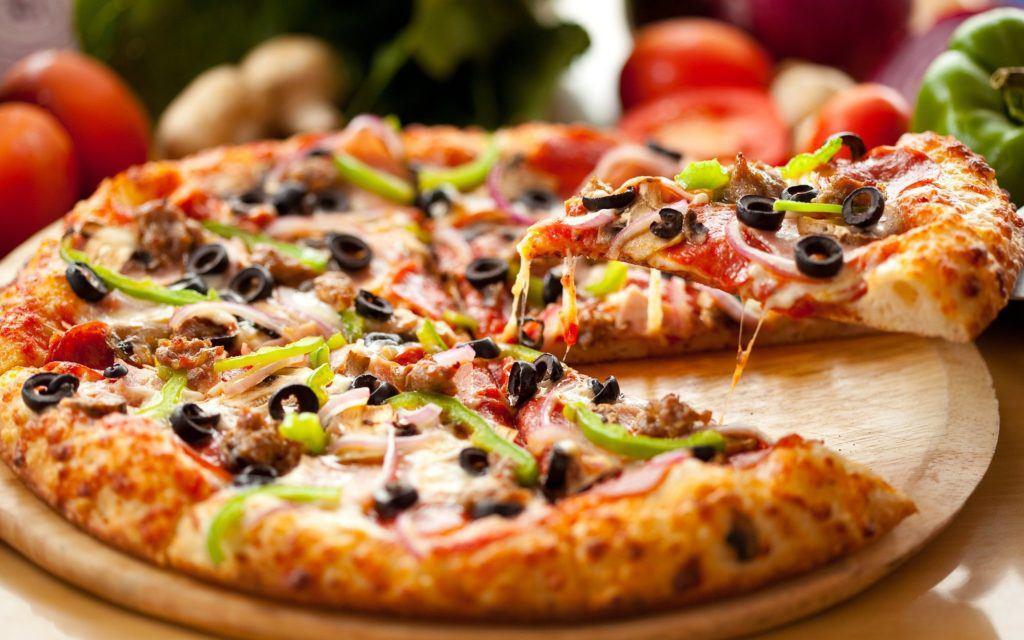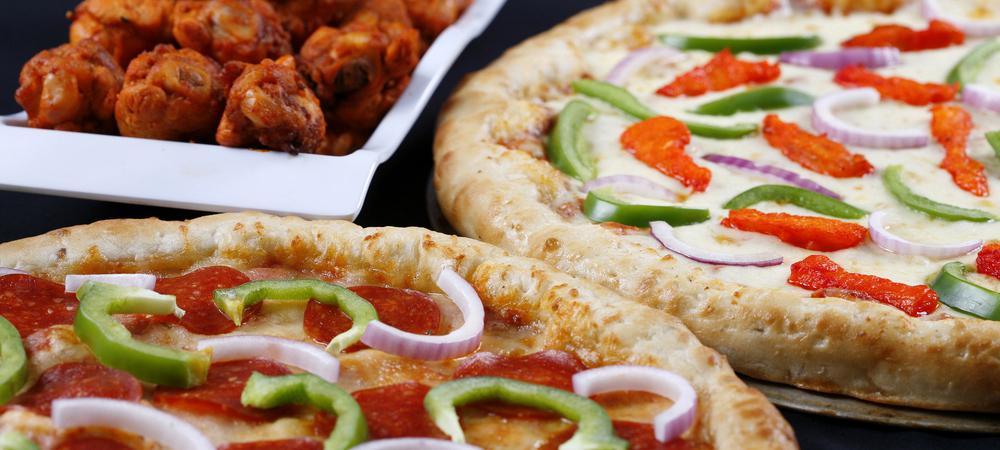The first image is the image on the left, the second image is the image on the right. For the images shown, is this caption "One image includes salads on plates, a green bell pepper and a small white bowl of orange shredded cheese near two pizzas." true? Answer yes or no. No. The first image is the image on the left, the second image is the image on the right. For the images shown, is this caption "An unopened container of soda is served with a pizza in one of the images." true? Answer yes or no. No. 